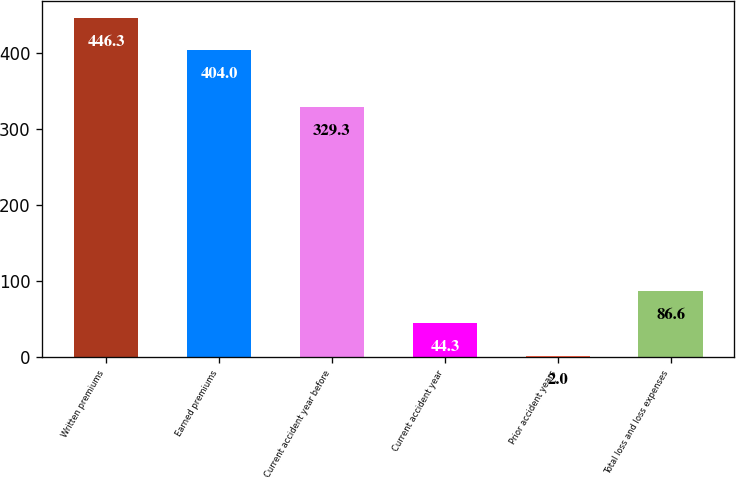<chart> <loc_0><loc_0><loc_500><loc_500><bar_chart><fcel>Written premiums<fcel>Earned premiums<fcel>Current accident year before<fcel>Current accident year<fcel>Prior accident years<fcel>Total loss and loss expenses<nl><fcel>446.3<fcel>404<fcel>329.3<fcel>44.3<fcel>2<fcel>86.6<nl></chart> 